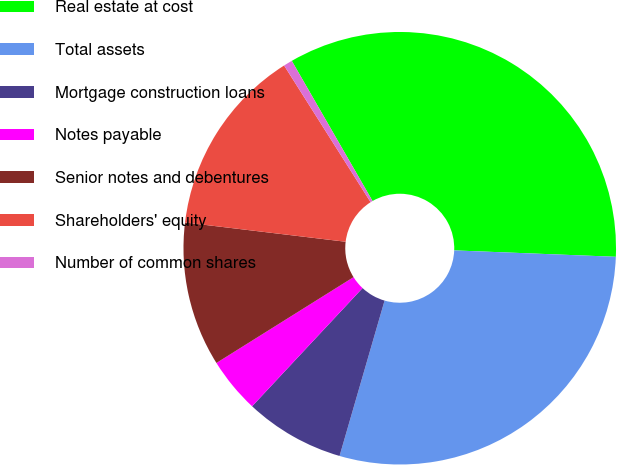Convert chart to OTSL. <chart><loc_0><loc_0><loc_500><loc_500><pie_chart><fcel>Real estate at cost<fcel>Total assets<fcel>Mortgage construction loans<fcel>Notes payable<fcel>Senior notes and debentures<fcel>Shareholders' equity<fcel>Number of common shares<nl><fcel>33.95%<fcel>28.86%<fcel>7.47%<fcel>4.14%<fcel>10.8%<fcel>14.12%<fcel>0.66%<nl></chart> 